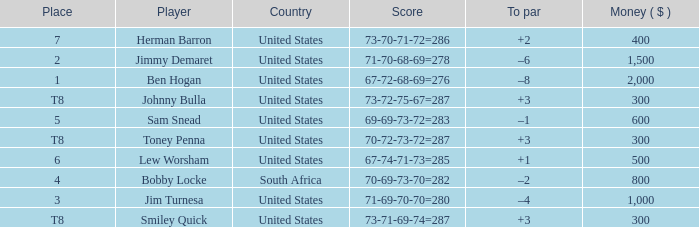What is the Place of the Player with Money greater than 300 and a Score of 71-69-70-70=280? 3.0. 